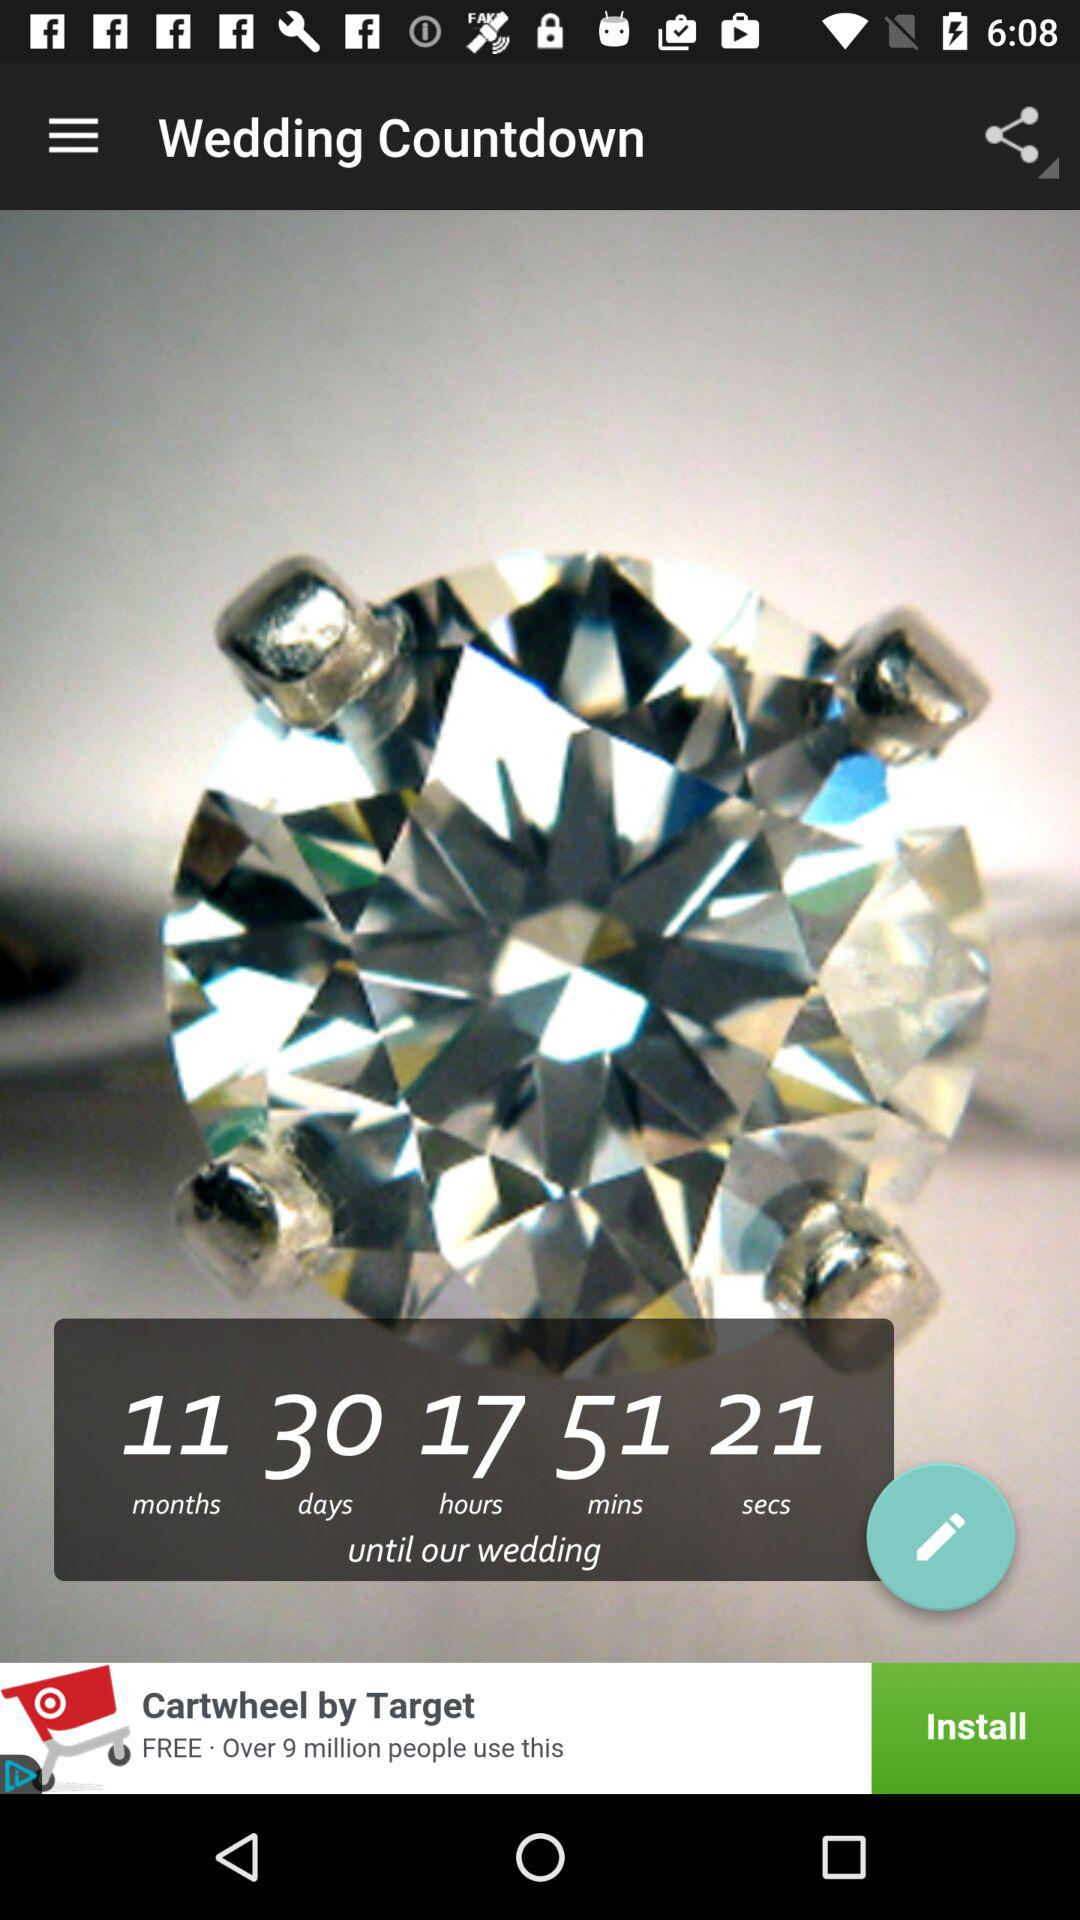What is the time remaining until our weeding? The remaining time is 11 months 30 days 17 hours 51 minutes 21 seconds. 